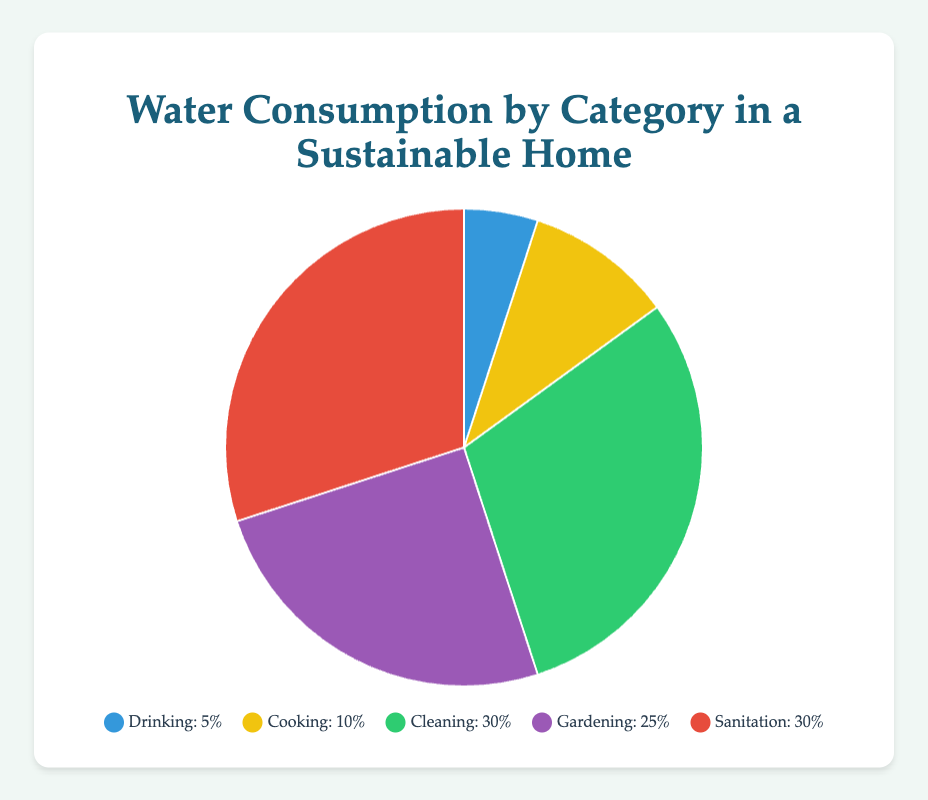What percentage of water consumption is used for sanitation? Look at the pie chart section labeled 'Sanitation' and see its associated percentage
Answer: 30% How much more water is used for cleaning compared to cooking? Identify the percentages for 'Cleaning' and 'Cooking'. Cleaning is 30% while Cooking is 10%. Subtract Cooking's percentage from Cleaning's percentage: 30% - 10%
Answer: 20% Which category uses the least amount of water? Examine all the percentages and find the smallest one, which corresponds to 'Drinking' at 5%
Answer: Drinking What two categories together make up 55% of water consumption? Find two categories whose combined percentages equal 55%. 'Gardening' and 'Sanitation' are 25% and 30% respectively: 25% + 30% = 55%
Answer: Gardening and Sanitation How does the water consumption for gardening compare to sanitation? Compare the percentages for 'Gardening' (25%) and 'Sanitation' (30%). Since 25% is less than 30%, Gardening uses less water than Sanitation
Answer: Less What's the average water consumption percentage for cleaning and cooking? Add the percentages for Cleaning (30%) and Cooking (10%), then divide by 2 to find the average: (30% + 10%) / 2 = 20%
Answer: 20% Which category uses 30% of the water? Identify the categories and their percentages. Both 'Cleaning' and 'Sanitation' are at 30%
Answer: Cleaning and Sanitation What percentage of water is used for activities other than sanitation? Subtract the sanitation percentage from 100%: 100% - 30% = 70%
Answer: 70% Is more water used for gardening or cooking? Compare their percentages. Gardening is 25% and Cooking is 10%. Gardening uses more water
Answer: Gardening What is the median percentage of water consumption across all categories? Arrange the percentages in ascending order: 5%, 10%, 25%, 30%, 30%. The middle value (third in this case) is 25%
Answer: 25% 